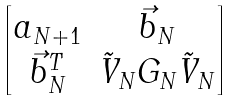<formula> <loc_0><loc_0><loc_500><loc_500>\begin{bmatrix} a _ { N + 1 } & \vec { b } _ { N } \\ \vec { b } _ { N } ^ { T } & \tilde { V } _ { N } G _ { N } \tilde { V } _ { N } \end{bmatrix}</formula> 